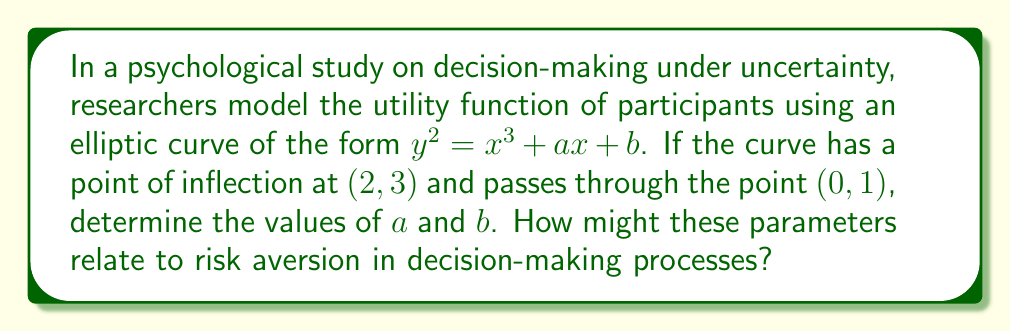Solve this math problem. Let's approach this step-by-step:

1) The general form of the elliptic curve is $y^2 = x^3 + ax + b$.

2) Given that the curve passes through $(0, 1)$, we can substitute these values:
   $1^2 = 0^3 + a(0) + b$
   $1 = b$

3) For the point of inflection $(2, 3)$, we need to use two conditions:
   a) The point satisfies the curve equation
   b) The second derivative of the curve is zero at this point

4) Substituting $(2, 3)$ into the curve equation:
   $3^2 = 2^3 + a(2) + 1$
   $9 = 8 + 2a + 1$
   $2a = 0$
   $a = 0$

5) To confirm this is a point of inflection, we need to check the second derivative:
   $\frac{d}{dx}(y^2) = \frac{d}{dx}(x^3 + ax + b)$
   $2y\frac{dy}{dx} = 3x^2 + a$
   $\frac{dy}{dx} = \frac{3x^2 + a}{2y}$

   $\frac{d^2y}{dx^2} = \frac{6x}{2y} - \frac{(3x^2 + a)^2}{4y^3}$

6) At the point of inflection, $\frac{d^2y}{dx^2} = 0$:
   $\frac{6(2)}{2(3)} - \frac{(3(2)^2 + 0)^2}{4(3)^3} = 0$
   $1 - \frac{36}{108} = 0$
   $1 - \frac{1}{3} = \frac{2}{3}$

This confirms that $(2, 3)$ is indeed a point of inflection.

7) Therefore, $a = 0$ and $b = 1$

In the context of decision-making processes, these parameters could relate to risk aversion as follows:
- The parameter $a$ (which is 0 in this case) might represent the linear component of risk attitude. A value of 0 suggests neutrality in small-scale decisions.
- The parameter $b$ (which is 1) could represent a baseline utility or satisfaction level. A positive value indicates a generally positive outlook in decision-making.

The shape of the curve, particularly the point of inflection, might indicate a change in risk attitude as the stakes of decisions increase.
Answer: $a = 0$, $b = 1$ 